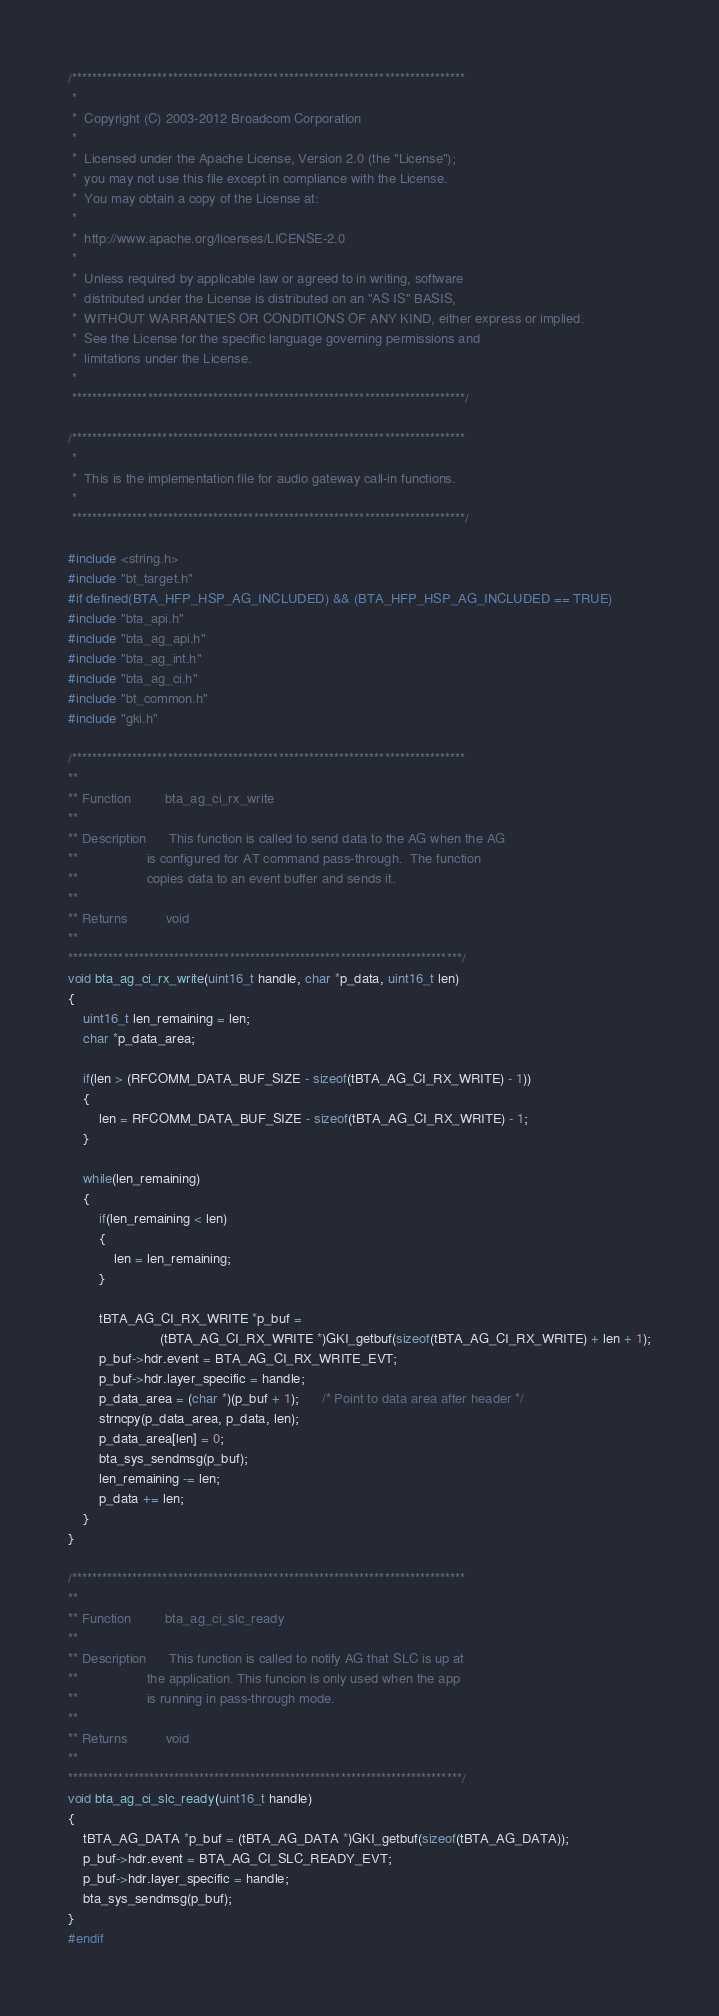Convert code to text. <code><loc_0><loc_0><loc_500><loc_500><_C_>/******************************************************************************
 *
 *  Copyright (C) 2003-2012 Broadcom Corporation
 *
 *  Licensed under the Apache License, Version 2.0 (the "License");
 *  you may not use this file except in compliance with the License.
 *  You may obtain a copy of the License at:
 *
 *  http://www.apache.org/licenses/LICENSE-2.0
 *
 *  Unless required by applicable law or agreed to in writing, software
 *  distributed under the License is distributed on an "AS IS" BASIS,
 *  WITHOUT WARRANTIES OR CONDITIONS OF ANY KIND, either express or implied.
 *  See the License for the specific language governing permissions and
 *  limitations under the License.
 *
 ******************************************************************************/

/******************************************************************************
 *
 *  This is the implementation file for audio gateway call-in functions.
 *
 ******************************************************************************/

#include <string.h>
#include "bt_target.h"
#if defined(BTA_HFP_HSP_AG_INCLUDED) && (BTA_HFP_HSP_AG_INCLUDED == TRUE)
#include "bta_api.h"
#include "bta_ag_api.h"
#include "bta_ag_int.h"
#include "bta_ag_ci.h"
#include "bt_common.h"
#include "gki.h"

/******************************************************************************
**
** Function         bta_ag_ci_rx_write
**
** Description      This function is called to send data to the AG when the AG
**                  is configured for AT command pass-through.  The function
**                  copies data to an event buffer and sends it.
**
** Returns          void
**
******************************************************************************/
void bta_ag_ci_rx_write(uint16_t handle, char *p_data, uint16_t len)
{
    uint16_t len_remaining = len;
    char *p_data_area;

    if(len > (RFCOMM_DATA_BUF_SIZE - sizeof(tBTA_AG_CI_RX_WRITE) - 1))
    {
        len = RFCOMM_DATA_BUF_SIZE - sizeof(tBTA_AG_CI_RX_WRITE) - 1;
    }

    while(len_remaining)
    {
        if(len_remaining < len)
        {
            len = len_remaining;
        }

        tBTA_AG_CI_RX_WRITE *p_buf =
                        (tBTA_AG_CI_RX_WRITE *)GKI_getbuf(sizeof(tBTA_AG_CI_RX_WRITE) + len + 1);
        p_buf->hdr.event = BTA_AG_CI_RX_WRITE_EVT;
        p_buf->hdr.layer_specific = handle;
        p_data_area = (char *)(p_buf + 1);      /* Point to data area after header */
        strncpy(p_data_area, p_data, len);
        p_data_area[len] = 0;
        bta_sys_sendmsg(p_buf);
        len_remaining -= len;
        p_data += len;
    }
}

/******************************************************************************
**
** Function         bta_ag_ci_slc_ready
**
** Description      This function is called to notify AG that SLC is up at
**                  the application. This funcion is only used when the app
**                  is running in pass-through mode.
**
** Returns          void
**
******************************************************************************/
void bta_ag_ci_slc_ready(uint16_t handle)
{
    tBTA_AG_DATA *p_buf = (tBTA_AG_DATA *)GKI_getbuf(sizeof(tBTA_AG_DATA));
    p_buf->hdr.event = BTA_AG_CI_SLC_READY_EVT;
    p_buf->hdr.layer_specific = handle;
    bta_sys_sendmsg(p_buf);
}
#endif
</code> 